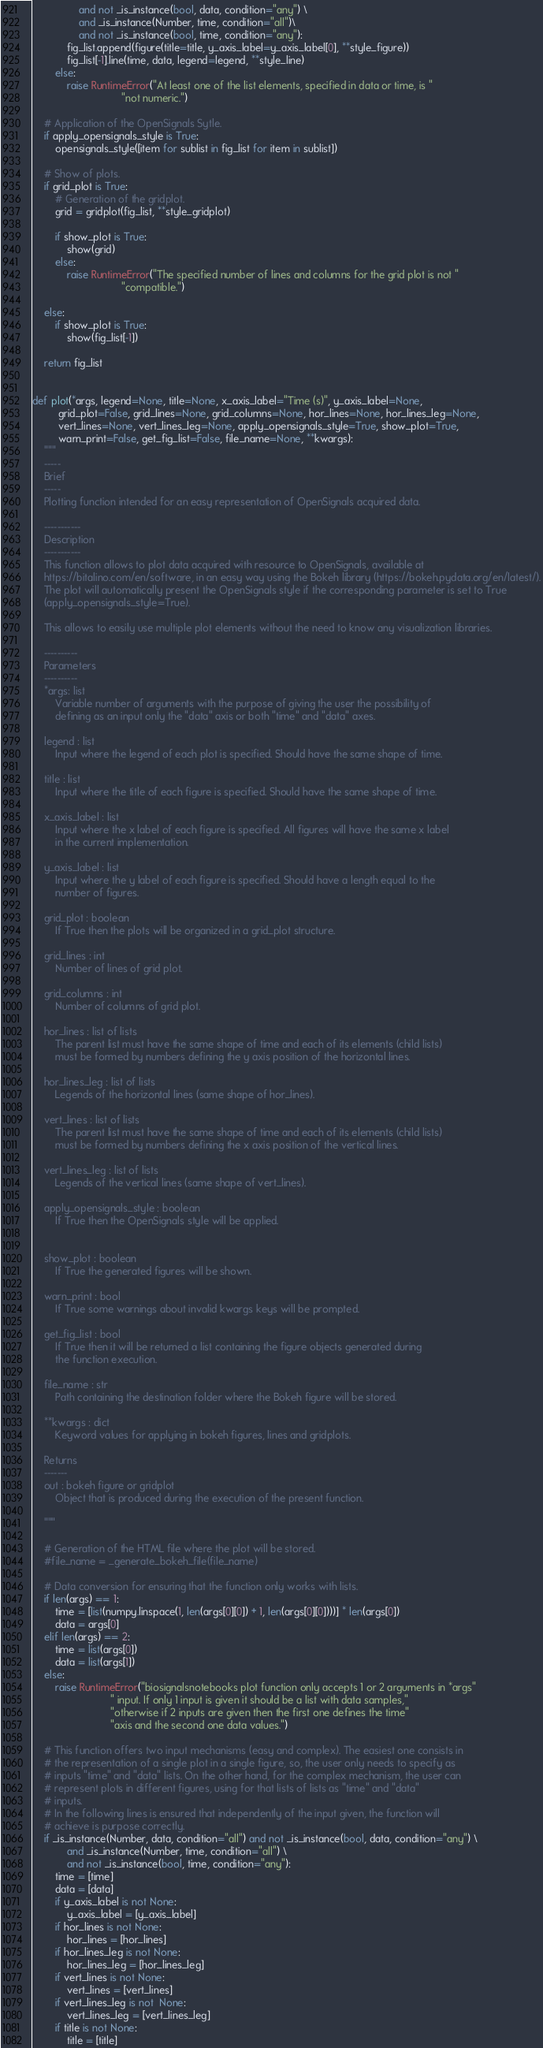<code> <loc_0><loc_0><loc_500><loc_500><_Python_>                and not _is_instance(bool, data, condition="any") \
                and _is_instance(Number, time, condition="all")\
                and not _is_instance(bool, time, condition="any"):
            fig_list.append(figure(title=title, y_axis_label=y_axis_label[0], **style_figure))
            fig_list[-1].line(time, data, legend=legend, **style_line)
        else:
            raise RuntimeError("At least one of the list elements, specified in data or time, is "
                               "not numeric.")

    # Application of the OpenSignals Sytle.
    if apply_opensignals_style is True:
        opensignals_style([item for sublist in fig_list for item in sublist])

    # Show of plots.
    if grid_plot is True:
        # Generation of the gridplot.
        grid = gridplot(fig_list, **style_gridplot)

        if show_plot is True:
            show(grid)
        else:
            raise RuntimeError("The specified number of lines and columns for the grid plot is not "
                               "compatible.")

    else:
        if show_plot is True:
            show(fig_list[-1])

    return fig_list


def plot(*args, legend=None, title=None, x_axis_label="Time (s)", y_axis_label=None,
         grid_plot=False, grid_lines=None, grid_columns=None, hor_lines=None, hor_lines_leg=None,
         vert_lines=None, vert_lines_leg=None, apply_opensignals_style=True, show_plot=True,
         warn_print=False, get_fig_list=False, file_name=None, **kwargs):
    """
    -----
    Brief
    -----
    Plotting function intended for an easy representation of OpenSignals acquired data.

    -----------
    Description
    -----------
    This function allows to plot data acquired with resource to OpenSignals, available at
    https://bitalino.com/en/software, in an easy way using the Bokeh library (https://bokeh.pydata.org/en/latest/).
    The plot will automatically present the OpenSignals style if the corresponding parameter is set to True
    (apply_opensignals_style=True).

    This allows to easily use multiple plot elements without the need to know any visualization libraries.

    ----------
    Parameters
    ----------
    *args: list
        Variable number of arguments with the purpose of giving the user the possibility of
        defining as an input only the "data" axis or both "time" and "data" axes.

    legend : list
        Input where the legend of each plot is specified. Should have the same shape of time.

    title : list
        Input where the title of each figure is specified. Should have the same shape of time.

    x_axis_label : list
        Input where the x label of each figure is specified. All figures will have the same x label
        in the current implementation.

    y_axis_label : list
        Input where the y label of each figure is specified. Should have a length equal to the
        number of figures.

    grid_plot : boolean
        If True then the plots will be organized in a grid_plot structure.

    grid_lines : int
        Number of lines of grid plot.

    grid_columns : int
        Number of columns of grid plot.

    hor_lines : list of lists
        The parent list must have the same shape of time and each of its elements (child lists)
        must be formed by numbers defining the y axis position of the horizontal lines.

    hor_lines_leg : list of lists
        Legends of the horizontal lines (same shape of hor_lines).

    vert_lines : list of lists
        The parent list must have the same shape of time and each of its elements (child lists)
        must be formed by numbers defining the x axis position of the vertical lines.

    vert_lines_leg : list of lists
        Legends of the vertical lines (same shape of vert_lines).

    apply_opensignals_style : boolean
        If True then the OpenSignals style will be applied.


    show_plot : boolean
        If True the generated figures will be shown.

    warn_print : bool
        If True some warnings about invalid kwargs keys will be prompted.

    get_fig_list : bool
        If True then it will be returned a list containing the figure objects generated during
        the function execution.

    file_name : str
        Path containing the destination folder where the Bokeh figure will be stored.

    **kwargs : dict
        Keyword values for applying in bokeh figures, lines and gridplots.

    Returns
    -------
    out : bokeh figure or gridplot
        Object that is produced during the execution of the present function.

    """

    # Generation of the HTML file where the plot will be stored.
    #file_name = _generate_bokeh_file(file_name)

    # Data conversion for ensuring that the function only works with lists.
    if len(args) == 1:
        time = [list(numpy.linspace(1, len(args[0][0]) + 1, len(args[0][0])))] * len(args[0])
        data = args[0]
    elif len(args) == 2:
        time = list(args[0])
        data = list(args[1])
    else:
        raise RuntimeError("biosignalsnotebooks plot function only accepts 1 or 2 arguments in *args"
                           " input. If only 1 input is given it should be a list with data samples,"
                           "otherwise if 2 inputs are given then the first one defines the time"
                           "axis and the second one data values.")

    # This function offers two input mechanisms (easy and complex). The easiest one consists in
    # the representation of a single plot in a single figure, so, the user only needs to specify as
    # inputs "time" and "data" lists. On the other hand, for the complex mechanism, the user can
    # represent plots in different figures, using for that lists of lists as "time" and "data"
    # inputs.
    # In the following lines is ensured that independently of the input given, the function will
    # achieve is purpose correctly.
    if _is_instance(Number, data, condition="all") and not _is_instance(bool, data, condition="any") \
            and _is_instance(Number, time, condition="all") \
            and not _is_instance(bool, time, condition="any"):
        time = [time]
        data = [data]
        if y_axis_label is not None:
            y_axis_label = [y_axis_label]
        if hor_lines is not None:
            hor_lines = [hor_lines]
        if hor_lines_leg is not None:
            hor_lines_leg = [hor_lines_leg]
        if vert_lines is not None:
            vert_lines = [vert_lines]
        if vert_lines_leg is not  None:
            vert_lines_leg = [vert_lines_leg]
        if title is not None:
            title = [title]</code> 